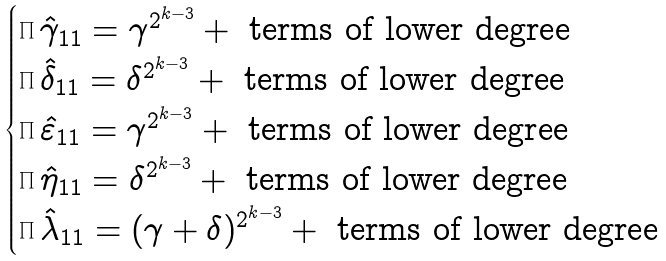Convert formula to latex. <formula><loc_0><loc_0><loc_500><loc_500>\begin{cases} \prod \hat { \gamma } _ { 1 1 } = \gamma ^ { 2 ^ { k - 3 } } + \text { terms of lower degree } \\ \prod \hat { \delta } _ { 1 1 } = \delta ^ { 2 ^ { k - 3 } } + \text { terms of lower degree } \\ \prod \hat { \varepsilon } _ { 1 1 } = \gamma ^ { 2 ^ { k - 3 } } + \text { terms of lower degree } \\ \prod \hat { \eta } _ { 1 1 } = \delta ^ { 2 ^ { k - 3 } } + \text { terms of lower degree } \\ \prod \hat { \lambda } _ { 1 1 } = ( \gamma + \delta ) ^ { 2 ^ { k - 3 } } + \text { terms of lower degree } \\ \end{cases}</formula> 